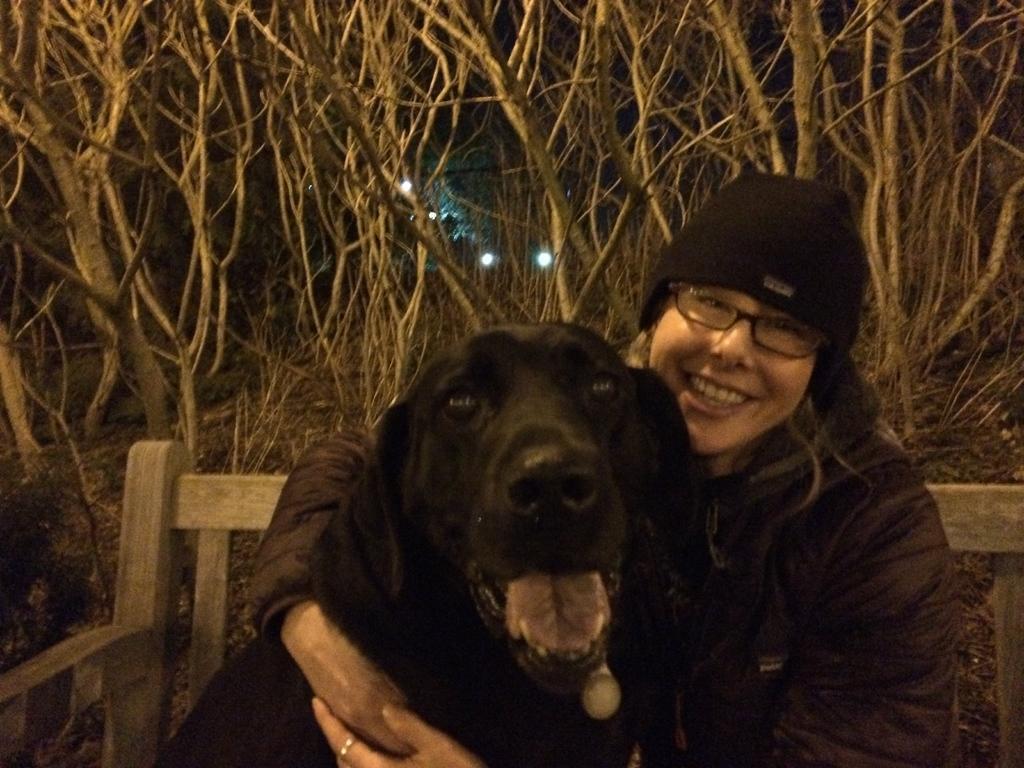Please provide a concise description of this image. As we can see in the image, there is a woman and black color dog sitting on bench. Behind them there are a lot of dry trees. 